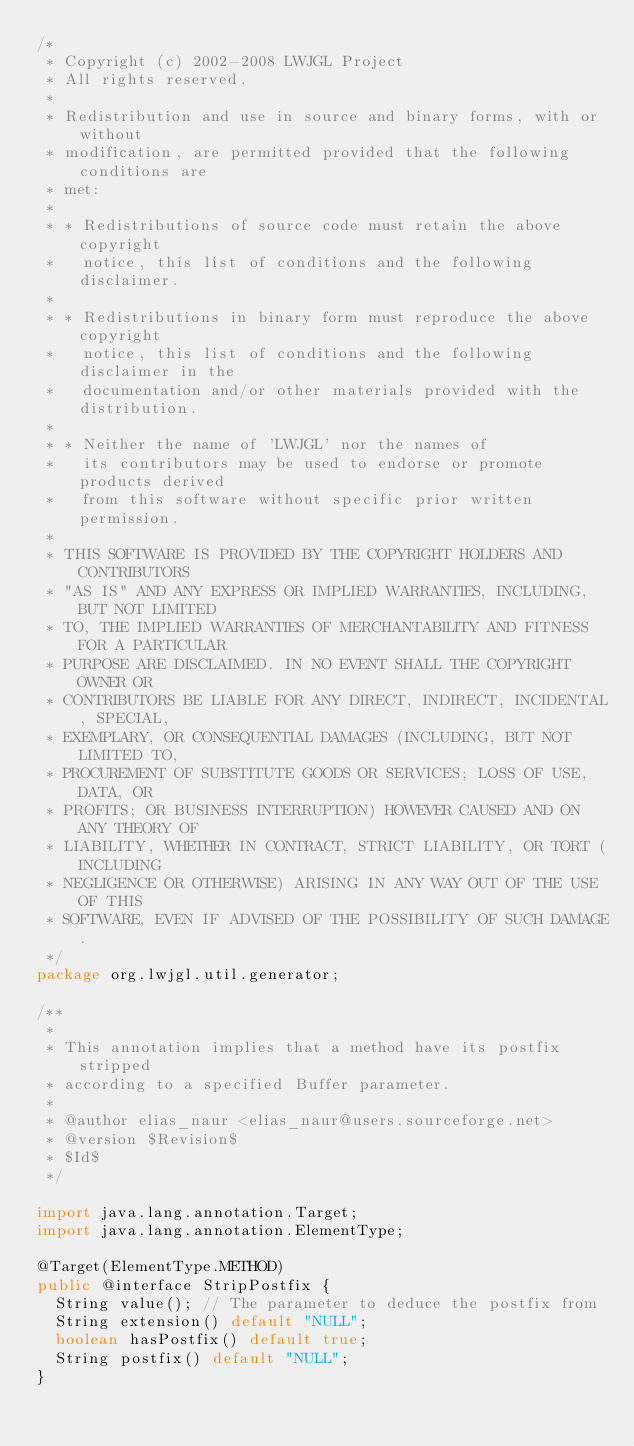Convert code to text. <code><loc_0><loc_0><loc_500><loc_500><_Java_>/*
 * Copyright (c) 2002-2008 LWJGL Project
 * All rights reserved.
 *
 * Redistribution and use in source and binary forms, with or without
 * modification, are permitted provided that the following conditions are
 * met:
 *
 * * Redistributions of source code must retain the above copyright
 *   notice, this list of conditions and the following disclaimer.
 *
 * * Redistributions in binary form must reproduce the above copyright
 *   notice, this list of conditions and the following disclaimer in the
 *   documentation and/or other materials provided with the distribution.
 *
 * * Neither the name of 'LWJGL' nor the names of
 *   its contributors may be used to endorse or promote products derived
 *   from this software without specific prior written permission.
 *
 * THIS SOFTWARE IS PROVIDED BY THE COPYRIGHT HOLDERS AND CONTRIBUTORS
 * "AS IS" AND ANY EXPRESS OR IMPLIED WARRANTIES, INCLUDING, BUT NOT LIMITED
 * TO, THE IMPLIED WARRANTIES OF MERCHANTABILITY AND FITNESS FOR A PARTICULAR
 * PURPOSE ARE DISCLAIMED. IN NO EVENT SHALL THE COPYRIGHT OWNER OR
 * CONTRIBUTORS BE LIABLE FOR ANY DIRECT, INDIRECT, INCIDENTAL, SPECIAL,
 * EXEMPLARY, OR CONSEQUENTIAL DAMAGES (INCLUDING, BUT NOT LIMITED TO,
 * PROCUREMENT OF SUBSTITUTE GOODS OR SERVICES; LOSS OF USE, DATA, OR
 * PROFITS; OR BUSINESS INTERRUPTION) HOWEVER CAUSED AND ON ANY THEORY OF
 * LIABILITY, WHETHER IN CONTRACT, STRICT LIABILITY, OR TORT (INCLUDING
 * NEGLIGENCE OR OTHERWISE) ARISING IN ANY WAY OUT OF THE USE OF THIS
 * SOFTWARE, EVEN IF ADVISED OF THE POSSIBILITY OF SUCH DAMAGE.
 */
package org.lwjgl.util.generator;

/**
 *
 * This annotation implies that a method have its postfix stripped
 * according to a specified Buffer parameter.
 *
 * @author elias_naur <elias_naur@users.sourceforge.net>
 * @version $Revision$
 * $Id$
 */

import java.lang.annotation.Target;
import java.lang.annotation.ElementType;

@Target(ElementType.METHOD)
public @interface StripPostfix {
	String value(); // The parameter to deduce the postfix from
	String extension() default "NULL";
	boolean hasPostfix() default true;
	String postfix() default "NULL";
}
</code> 